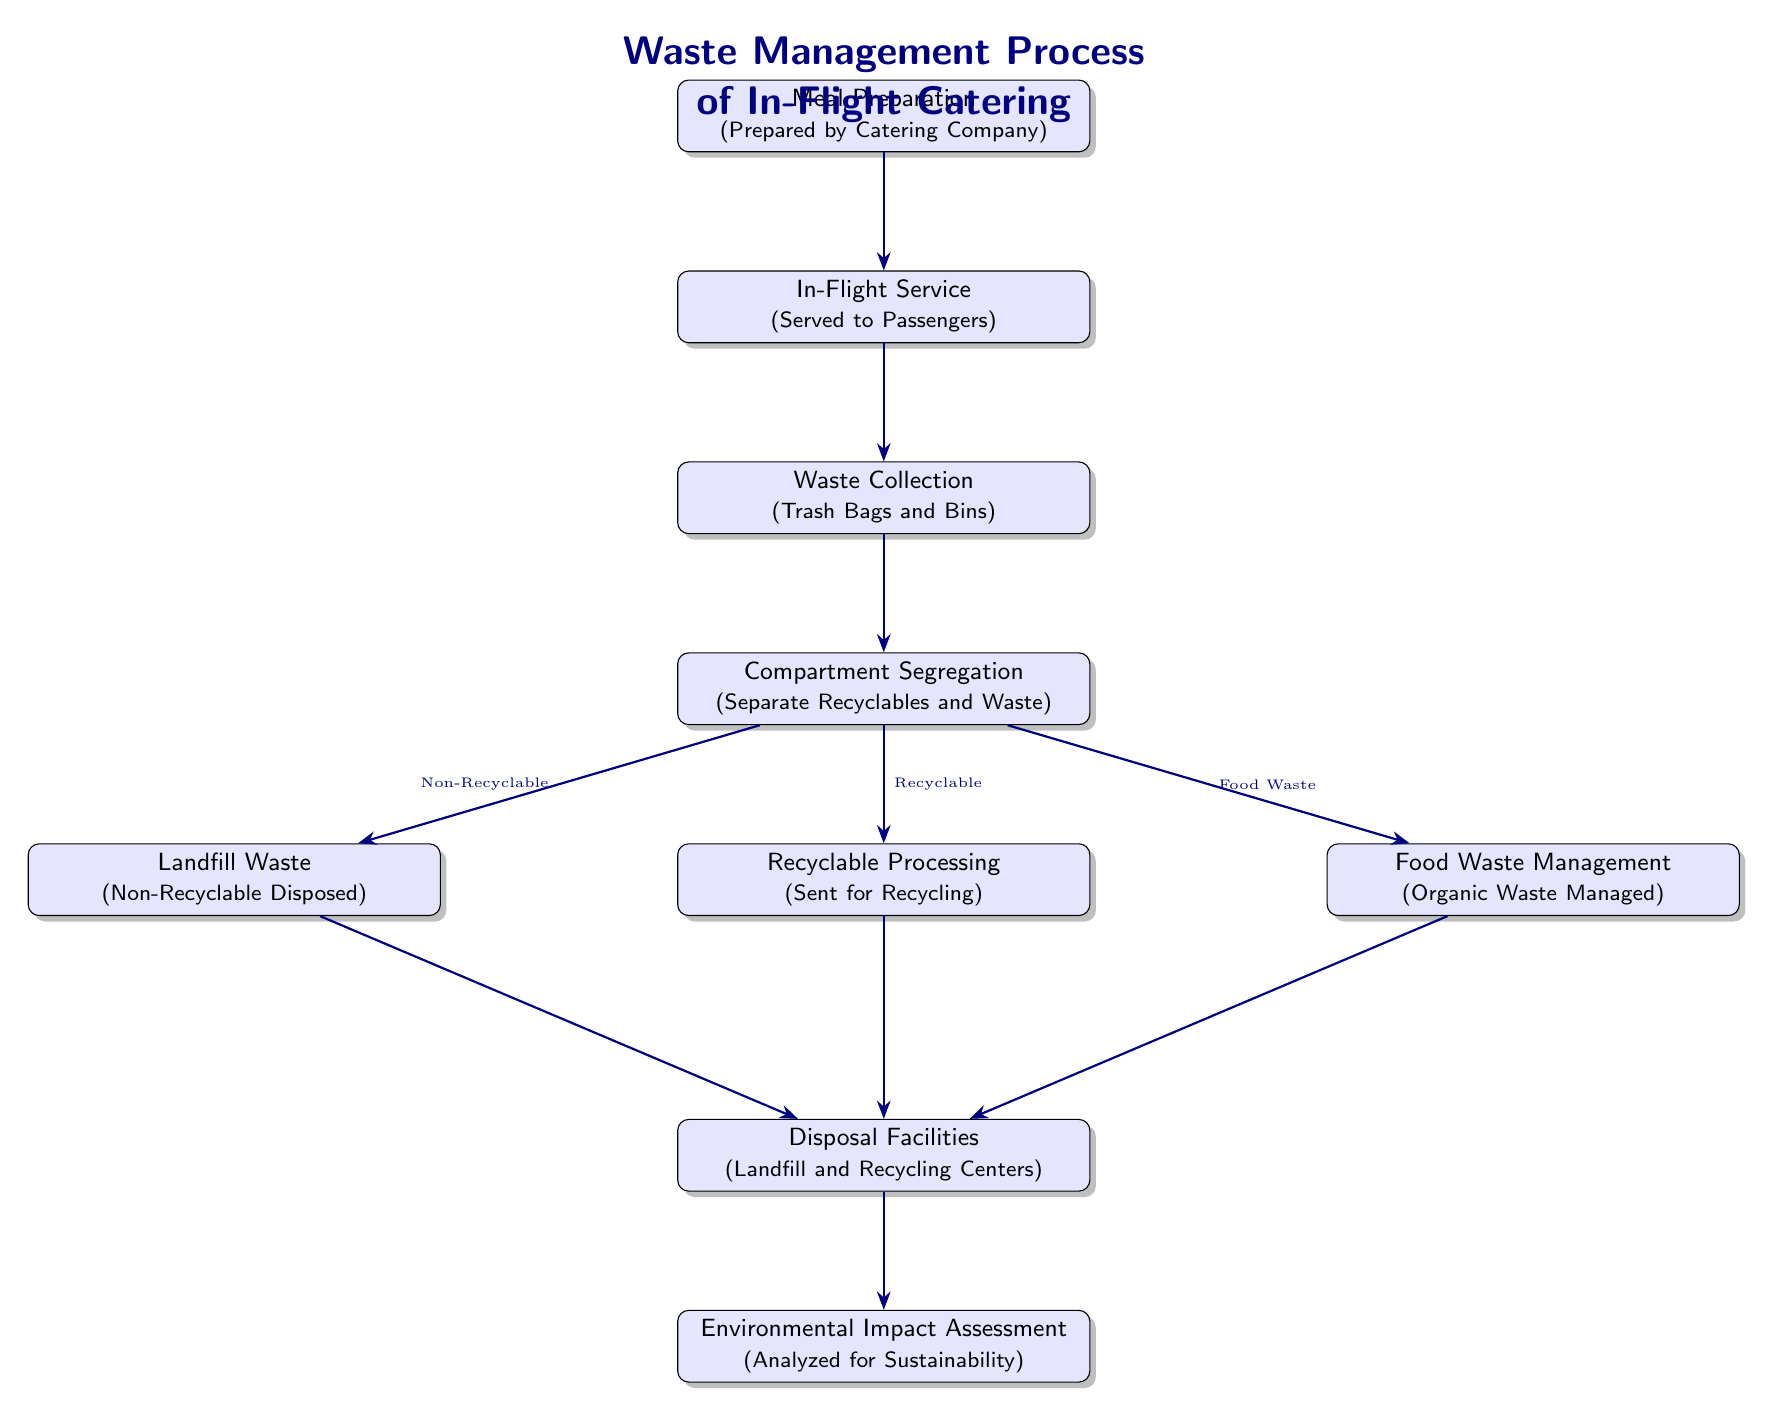What is the first step in the waste management process? The first node in the diagram is "Meal Preparation", which indicates that the waste management process begins with meal preparation by the catering company.
Answer: Meal Preparation How many total nodes are in the diagram? The diagram contains 9 nodes, each representing a different stage in the waste management process from meal preparation to environmental impact assessment.
Answer: 9 What waste type is sent for recycling? The node labeled "Recyclable Processing" is directly linked to the "Compartment Segregation" node, indicating that recyclable waste is processed after segregation.
Answer: Recyclable From which node is food waste managed? Food waste is managed starting from the "Compartment Segregation" node, where food waste is separated and directed to the "Food Waste Management" node.
Answer: Food Waste Management What is the final step in the waste management process? The final node presents "Environmental Impact Assessment", which indicates that after disposal facilities, the environmental impacts are analyzed for sustainability.
Answer: Environmental Impact Assessment What are the three types of waste resulting from compartment segregation? The "Compartment Segregation" node specifies that three types of waste result from this stage: Non-Recyclable, Recyclable, and Food Waste.
Answer: Non-Recyclable, Recyclable, Food Waste How does landfill waste travel through the process? The diagram shows that landfill waste is directed from the "Compartment Segregation" node to "Landfill Waste", and then moves to "Disposal Facilities".
Answer: Through to Disposal Facilities Which process follows waste collection? The "Compartment Segregation" node follows waste collection in the waste management process, where the collected waste is sorted into different categories.
Answer: Compartment Segregation What does the waste management process assess at the end? The final step in the process, represented by the last node, is the environmental impact assessment, which evaluates the sustainability of the waste management practices implemented.
Answer: Sustainability 